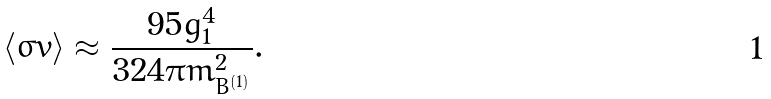<formula> <loc_0><loc_0><loc_500><loc_500>\langle \sigma v \rangle \approx \frac { 9 5 g ^ { 4 } _ { 1 } } { 3 2 4 \pi m ^ { 2 } _ { B ^ { ( 1 ) } } } .</formula> 